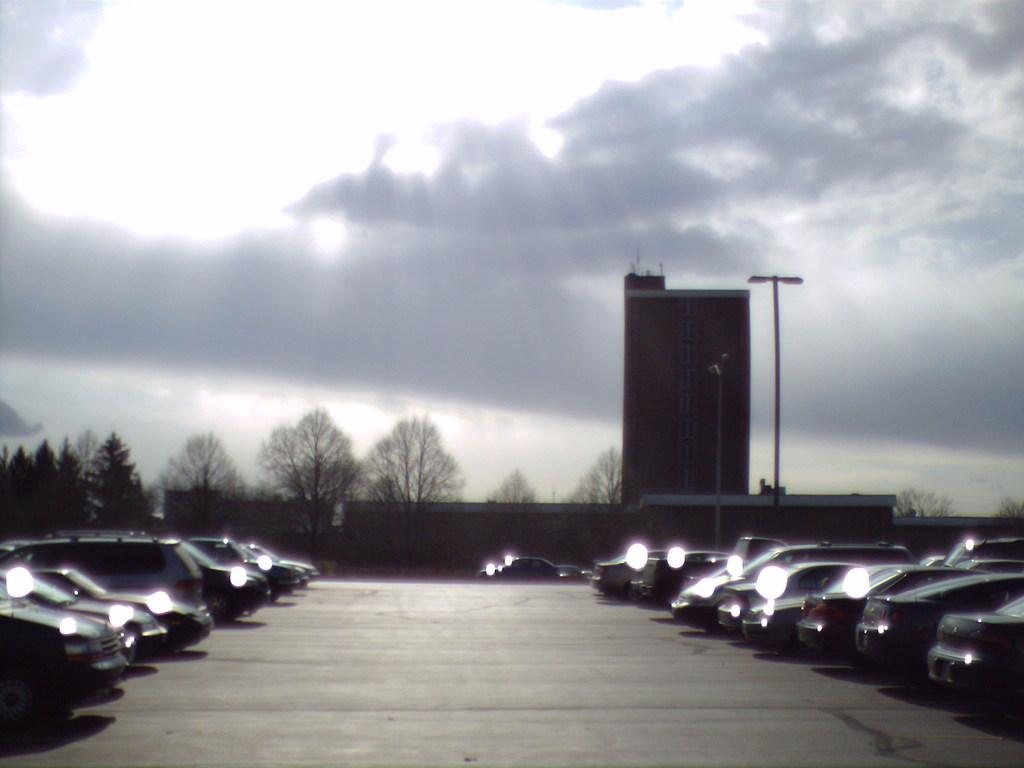What types of objects are on the ground in the image? There are vehicles on the ground in the image. What is the tall structure in the image? There is a wall in the image. What type of man-made structure is visible in the image? There is a building in the image. What are the long, thin structures in the image? There are poles in the image. What type of natural vegetation is present in the image? There are trees in the image. What is visible in the background of the image? The sky is visible in the background of the image. What can be seen in the sky in the image? Clouds are present in the sky. What type of brass instrument is being played by the ant in the image? There is no brass instrument or ant present in the image. How does the society depicted in the image function? The image does not depict a society, so it is not possible to determine how it functions. 